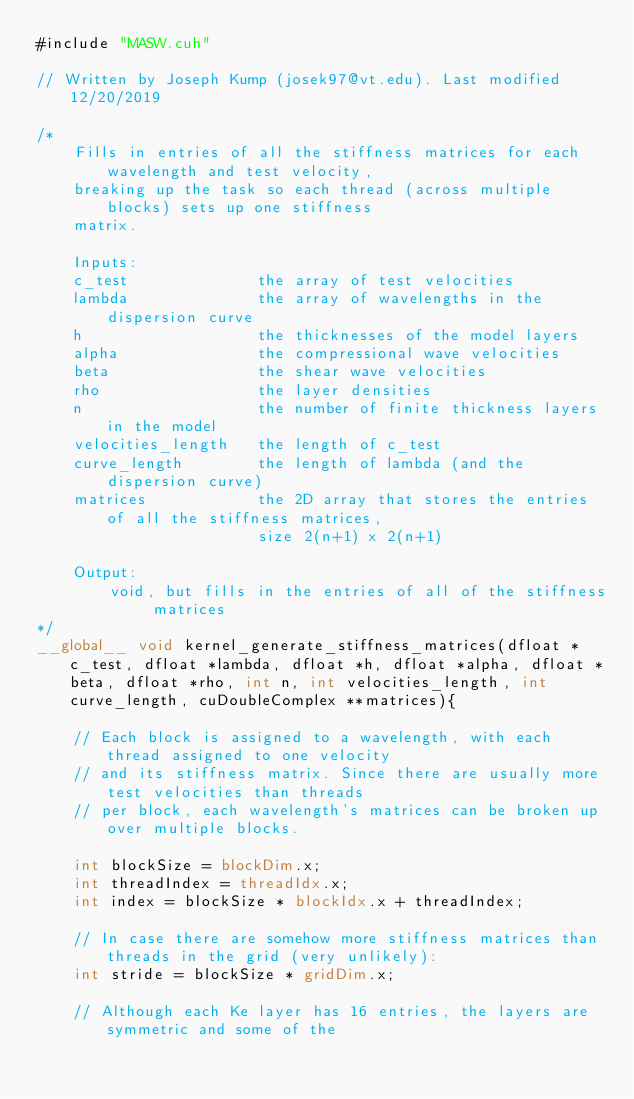Convert code to text. <code><loc_0><loc_0><loc_500><loc_500><_Cuda_>#include "MASW.cuh"

// Written by Joseph Kump (josek97@vt.edu). Last modified 12/20/2019

/*
    Fills in entries of all the stiffness matrices for each wavelength and test velocity,
    breaking up the task so each thread (across multiple blocks) sets up one stiffness
    matrix.
    
    Inputs:
    c_test              the array of test velocities
    lambda              the array of wavelengths in the dispersion curve
    h                   the thicknesses of the model layers
    alpha               the compressional wave velocities
    beta                the shear wave velocities
    rho                 the layer densities
    n                   the number of finite thickness layers in the model
    velocities_length   the length of c_test
    curve_length        the length of lambda (and the dispersion curve)
    matrices            the 2D array that stores the entries of all the stiffness matrices,
                        size 2(n+1) x 2(n+1)
                        
    Output:
        void, but fills in the entries of all of the stiffness matrices
*/
__global__ void kernel_generate_stiffness_matrices(dfloat *c_test, dfloat *lambda, dfloat *h, dfloat *alpha, dfloat *beta, dfloat *rho, int n, int velocities_length, int curve_length, cuDoubleComplex **matrices){

    // Each block is assigned to a wavelength, with each thread assigned to one velocity
    // and its stiffness matrix. Since there are usually more test velocities than threads
    // per block, each wavelength's matrices can be broken up over multiple blocks.
    
    int blockSize = blockDim.x;
    int threadIndex = threadIdx.x;
    int index = blockSize * blockIdx.x + threadIndex;
    
    // In case there are somehow more stiffness matrices than threads in the grid (very unlikely):
    int stride = blockSize * gridDim.x;
    
    // Although each Ke layer has 16 entries, the layers are symmetric and some of the </code> 